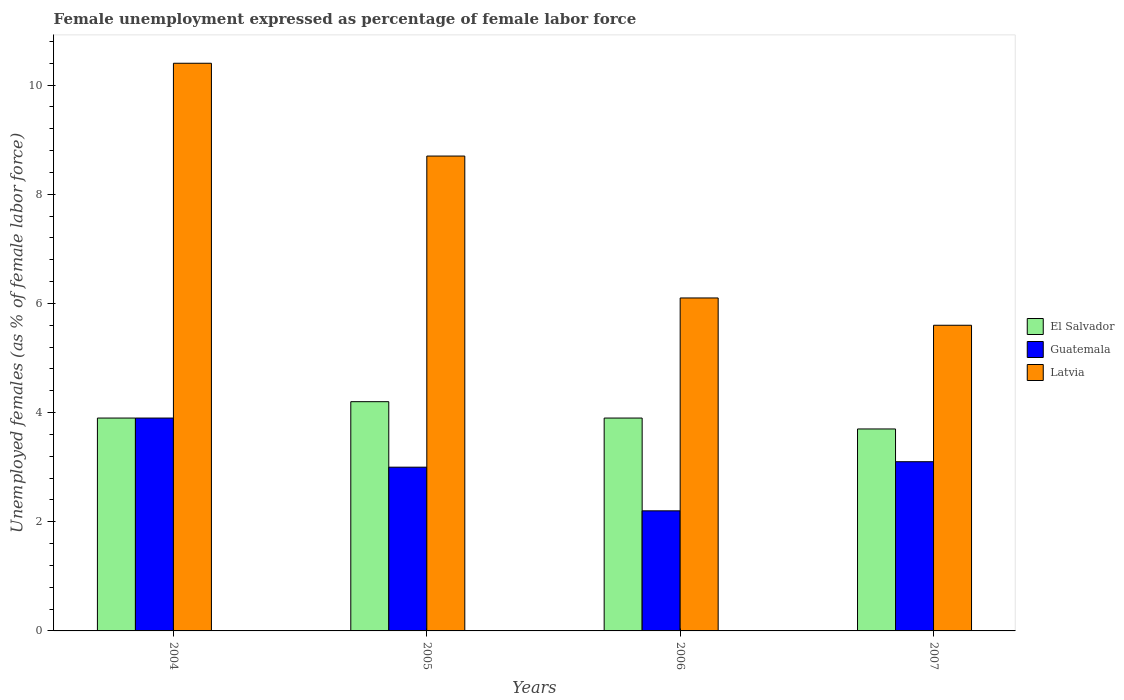Are the number of bars per tick equal to the number of legend labels?
Provide a short and direct response. Yes. Are the number of bars on each tick of the X-axis equal?
Make the answer very short. Yes. How many bars are there on the 4th tick from the left?
Offer a very short reply. 3. How many bars are there on the 4th tick from the right?
Ensure brevity in your answer.  3. In how many cases, is the number of bars for a given year not equal to the number of legend labels?
Offer a terse response. 0. What is the unemployment in females in in Latvia in 2006?
Your answer should be very brief. 6.1. Across all years, what is the maximum unemployment in females in in Guatemala?
Make the answer very short. 3.9. Across all years, what is the minimum unemployment in females in in El Salvador?
Your answer should be compact. 3.7. What is the total unemployment in females in in El Salvador in the graph?
Offer a terse response. 15.7. What is the difference between the unemployment in females in in El Salvador in 2004 and that in 2007?
Provide a succinct answer. 0.2. What is the difference between the unemployment in females in in El Salvador in 2007 and the unemployment in females in in Latvia in 2005?
Make the answer very short. -5. What is the average unemployment in females in in El Salvador per year?
Keep it short and to the point. 3.93. In the year 2004, what is the difference between the unemployment in females in in Latvia and unemployment in females in in Guatemala?
Offer a very short reply. 6.5. In how many years, is the unemployment in females in in Latvia greater than 8 %?
Offer a very short reply. 2. What is the ratio of the unemployment in females in in Guatemala in 2004 to that in 2007?
Your response must be concise. 1.26. Is the unemployment in females in in Latvia in 2004 less than that in 2005?
Offer a terse response. No. Is the difference between the unemployment in females in in Latvia in 2006 and 2007 greater than the difference between the unemployment in females in in Guatemala in 2006 and 2007?
Ensure brevity in your answer.  Yes. What is the difference between the highest and the second highest unemployment in females in in Guatemala?
Provide a succinct answer. 0.8. What is the difference between the highest and the lowest unemployment in females in in Guatemala?
Your answer should be very brief. 1.7. What does the 1st bar from the left in 2007 represents?
Your response must be concise. El Salvador. What does the 2nd bar from the right in 2007 represents?
Provide a short and direct response. Guatemala. How many years are there in the graph?
Give a very brief answer. 4. Are the values on the major ticks of Y-axis written in scientific E-notation?
Your answer should be very brief. No. Where does the legend appear in the graph?
Your response must be concise. Center right. How many legend labels are there?
Keep it short and to the point. 3. What is the title of the graph?
Ensure brevity in your answer.  Female unemployment expressed as percentage of female labor force. Does "Luxembourg" appear as one of the legend labels in the graph?
Provide a short and direct response. No. What is the label or title of the Y-axis?
Give a very brief answer. Unemployed females (as % of female labor force). What is the Unemployed females (as % of female labor force) of El Salvador in 2004?
Give a very brief answer. 3.9. What is the Unemployed females (as % of female labor force) of Guatemala in 2004?
Give a very brief answer. 3.9. What is the Unemployed females (as % of female labor force) in Latvia in 2004?
Provide a succinct answer. 10.4. What is the Unemployed females (as % of female labor force) in El Salvador in 2005?
Your answer should be very brief. 4.2. What is the Unemployed females (as % of female labor force) of Guatemala in 2005?
Offer a terse response. 3. What is the Unemployed females (as % of female labor force) in Latvia in 2005?
Provide a succinct answer. 8.7. What is the Unemployed females (as % of female labor force) in El Salvador in 2006?
Provide a succinct answer. 3.9. What is the Unemployed females (as % of female labor force) of Guatemala in 2006?
Provide a short and direct response. 2.2. What is the Unemployed females (as % of female labor force) of Latvia in 2006?
Your answer should be very brief. 6.1. What is the Unemployed females (as % of female labor force) in El Salvador in 2007?
Make the answer very short. 3.7. What is the Unemployed females (as % of female labor force) in Guatemala in 2007?
Provide a succinct answer. 3.1. What is the Unemployed females (as % of female labor force) of Latvia in 2007?
Make the answer very short. 5.6. Across all years, what is the maximum Unemployed females (as % of female labor force) of El Salvador?
Ensure brevity in your answer.  4.2. Across all years, what is the maximum Unemployed females (as % of female labor force) in Guatemala?
Your answer should be very brief. 3.9. Across all years, what is the maximum Unemployed females (as % of female labor force) in Latvia?
Your answer should be very brief. 10.4. Across all years, what is the minimum Unemployed females (as % of female labor force) in El Salvador?
Make the answer very short. 3.7. Across all years, what is the minimum Unemployed females (as % of female labor force) of Guatemala?
Make the answer very short. 2.2. Across all years, what is the minimum Unemployed females (as % of female labor force) in Latvia?
Give a very brief answer. 5.6. What is the total Unemployed females (as % of female labor force) in Latvia in the graph?
Make the answer very short. 30.8. What is the difference between the Unemployed females (as % of female labor force) in Latvia in 2004 and that in 2005?
Make the answer very short. 1.7. What is the difference between the Unemployed females (as % of female labor force) of Guatemala in 2004 and that in 2006?
Offer a very short reply. 1.7. What is the difference between the Unemployed females (as % of female labor force) of Latvia in 2004 and that in 2006?
Your answer should be compact. 4.3. What is the difference between the Unemployed females (as % of female labor force) of Latvia in 2004 and that in 2007?
Keep it short and to the point. 4.8. What is the difference between the Unemployed females (as % of female labor force) of El Salvador in 2005 and that in 2006?
Provide a succinct answer. 0.3. What is the difference between the Unemployed females (as % of female labor force) in Guatemala in 2005 and that in 2006?
Your answer should be compact. 0.8. What is the difference between the Unemployed females (as % of female labor force) in Guatemala in 2005 and that in 2007?
Offer a terse response. -0.1. What is the difference between the Unemployed females (as % of female labor force) in Latvia in 2006 and that in 2007?
Offer a terse response. 0.5. What is the difference between the Unemployed females (as % of female labor force) in El Salvador in 2004 and the Unemployed females (as % of female labor force) in Guatemala in 2005?
Provide a succinct answer. 0.9. What is the difference between the Unemployed females (as % of female labor force) of El Salvador in 2004 and the Unemployed females (as % of female labor force) of Latvia in 2005?
Provide a succinct answer. -4.8. What is the difference between the Unemployed females (as % of female labor force) in El Salvador in 2004 and the Unemployed females (as % of female labor force) in Guatemala in 2006?
Ensure brevity in your answer.  1.7. What is the difference between the Unemployed females (as % of female labor force) in El Salvador in 2004 and the Unemployed females (as % of female labor force) in Latvia in 2006?
Ensure brevity in your answer.  -2.2. What is the difference between the Unemployed females (as % of female labor force) of Guatemala in 2004 and the Unemployed females (as % of female labor force) of Latvia in 2007?
Your answer should be very brief. -1.7. What is the difference between the Unemployed females (as % of female labor force) of El Salvador in 2005 and the Unemployed females (as % of female labor force) of Latvia in 2006?
Your answer should be very brief. -1.9. What is the average Unemployed females (as % of female labor force) of El Salvador per year?
Make the answer very short. 3.92. What is the average Unemployed females (as % of female labor force) in Guatemala per year?
Offer a very short reply. 3.05. In the year 2004, what is the difference between the Unemployed females (as % of female labor force) in El Salvador and Unemployed females (as % of female labor force) in Guatemala?
Offer a terse response. 0. In the year 2004, what is the difference between the Unemployed females (as % of female labor force) in El Salvador and Unemployed females (as % of female labor force) in Latvia?
Offer a very short reply. -6.5. In the year 2004, what is the difference between the Unemployed females (as % of female labor force) in Guatemala and Unemployed females (as % of female labor force) in Latvia?
Make the answer very short. -6.5. In the year 2005, what is the difference between the Unemployed females (as % of female labor force) of El Salvador and Unemployed females (as % of female labor force) of Latvia?
Give a very brief answer. -4.5. In the year 2005, what is the difference between the Unemployed females (as % of female labor force) in Guatemala and Unemployed females (as % of female labor force) in Latvia?
Ensure brevity in your answer.  -5.7. In the year 2006, what is the difference between the Unemployed females (as % of female labor force) of Guatemala and Unemployed females (as % of female labor force) of Latvia?
Make the answer very short. -3.9. In the year 2007, what is the difference between the Unemployed females (as % of female labor force) of El Salvador and Unemployed females (as % of female labor force) of Guatemala?
Keep it short and to the point. 0.6. In the year 2007, what is the difference between the Unemployed females (as % of female labor force) of El Salvador and Unemployed females (as % of female labor force) of Latvia?
Keep it short and to the point. -1.9. In the year 2007, what is the difference between the Unemployed females (as % of female labor force) of Guatemala and Unemployed females (as % of female labor force) of Latvia?
Give a very brief answer. -2.5. What is the ratio of the Unemployed females (as % of female labor force) of Latvia in 2004 to that in 2005?
Offer a terse response. 1.2. What is the ratio of the Unemployed females (as % of female labor force) of Guatemala in 2004 to that in 2006?
Your answer should be very brief. 1.77. What is the ratio of the Unemployed females (as % of female labor force) of Latvia in 2004 to that in 2006?
Provide a short and direct response. 1.7. What is the ratio of the Unemployed females (as % of female labor force) of El Salvador in 2004 to that in 2007?
Keep it short and to the point. 1.05. What is the ratio of the Unemployed females (as % of female labor force) of Guatemala in 2004 to that in 2007?
Provide a short and direct response. 1.26. What is the ratio of the Unemployed females (as % of female labor force) of Latvia in 2004 to that in 2007?
Ensure brevity in your answer.  1.86. What is the ratio of the Unemployed females (as % of female labor force) in Guatemala in 2005 to that in 2006?
Keep it short and to the point. 1.36. What is the ratio of the Unemployed females (as % of female labor force) of Latvia in 2005 to that in 2006?
Ensure brevity in your answer.  1.43. What is the ratio of the Unemployed females (as % of female labor force) in El Salvador in 2005 to that in 2007?
Offer a terse response. 1.14. What is the ratio of the Unemployed females (as % of female labor force) in Latvia in 2005 to that in 2007?
Ensure brevity in your answer.  1.55. What is the ratio of the Unemployed females (as % of female labor force) of El Salvador in 2006 to that in 2007?
Offer a terse response. 1.05. What is the ratio of the Unemployed females (as % of female labor force) of Guatemala in 2006 to that in 2007?
Offer a terse response. 0.71. What is the ratio of the Unemployed females (as % of female labor force) of Latvia in 2006 to that in 2007?
Your answer should be very brief. 1.09. What is the difference between the highest and the lowest Unemployed females (as % of female labor force) of Latvia?
Ensure brevity in your answer.  4.8. 